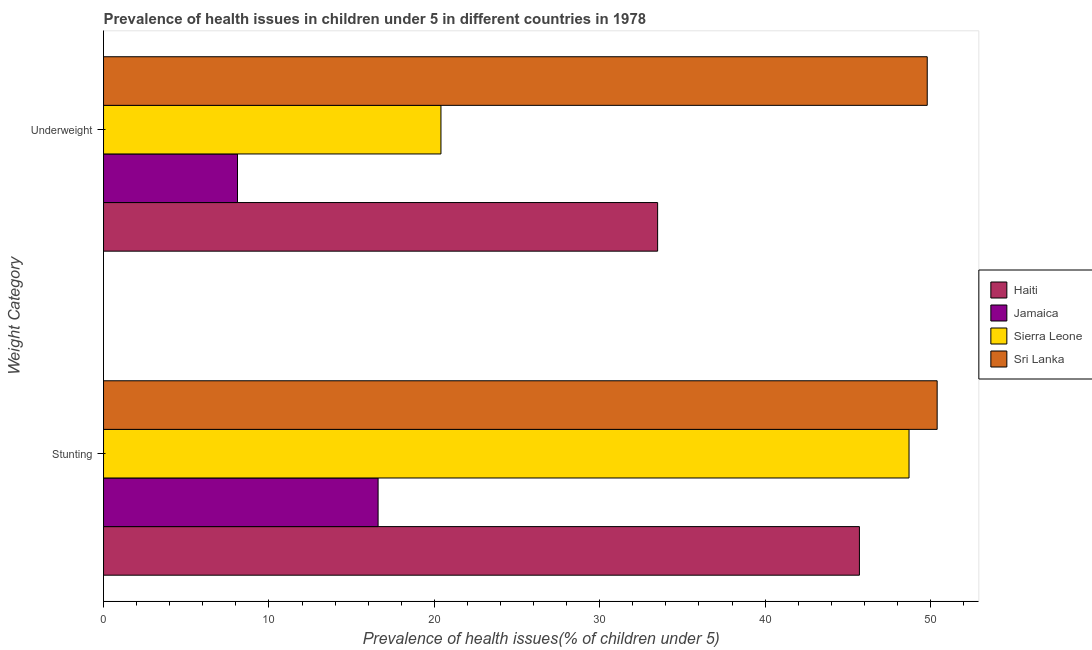How many different coloured bars are there?
Ensure brevity in your answer.  4. Are the number of bars on each tick of the Y-axis equal?
Your answer should be very brief. Yes. How many bars are there on the 2nd tick from the top?
Provide a succinct answer. 4. What is the label of the 2nd group of bars from the top?
Offer a very short reply. Stunting. What is the percentage of underweight children in Sierra Leone?
Your answer should be compact. 20.4. Across all countries, what is the maximum percentage of underweight children?
Your answer should be very brief. 49.8. Across all countries, what is the minimum percentage of underweight children?
Your answer should be compact. 8.1. In which country was the percentage of stunted children maximum?
Offer a terse response. Sri Lanka. In which country was the percentage of stunted children minimum?
Offer a terse response. Jamaica. What is the total percentage of stunted children in the graph?
Your response must be concise. 161.4. What is the difference between the percentage of stunted children in Haiti and that in Jamaica?
Give a very brief answer. 29.1. What is the difference between the percentage of stunted children in Haiti and the percentage of underweight children in Sri Lanka?
Provide a succinct answer. -4.1. What is the average percentage of stunted children per country?
Provide a succinct answer. 40.35. What is the difference between the percentage of underweight children and percentage of stunted children in Jamaica?
Make the answer very short. -8.5. What is the ratio of the percentage of stunted children in Jamaica to that in Haiti?
Provide a short and direct response. 0.36. Is the percentage of underweight children in Haiti less than that in Jamaica?
Keep it short and to the point. No. In how many countries, is the percentage of stunted children greater than the average percentage of stunted children taken over all countries?
Make the answer very short. 3. What does the 3rd bar from the top in Underweight represents?
Give a very brief answer. Jamaica. What does the 4th bar from the bottom in Stunting represents?
Your answer should be very brief. Sri Lanka. Are all the bars in the graph horizontal?
Your response must be concise. Yes. How many countries are there in the graph?
Your response must be concise. 4. Does the graph contain any zero values?
Keep it short and to the point. No. How are the legend labels stacked?
Your response must be concise. Vertical. What is the title of the graph?
Keep it short and to the point. Prevalence of health issues in children under 5 in different countries in 1978. Does "Cuba" appear as one of the legend labels in the graph?
Keep it short and to the point. No. What is the label or title of the X-axis?
Ensure brevity in your answer.  Prevalence of health issues(% of children under 5). What is the label or title of the Y-axis?
Provide a succinct answer. Weight Category. What is the Prevalence of health issues(% of children under 5) in Haiti in Stunting?
Provide a succinct answer. 45.7. What is the Prevalence of health issues(% of children under 5) in Jamaica in Stunting?
Your answer should be very brief. 16.6. What is the Prevalence of health issues(% of children under 5) of Sierra Leone in Stunting?
Your answer should be compact. 48.7. What is the Prevalence of health issues(% of children under 5) of Sri Lanka in Stunting?
Ensure brevity in your answer.  50.4. What is the Prevalence of health issues(% of children under 5) in Haiti in Underweight?
Provide a short and direct response. 33.5. What is the Prevalence of health issues(% of children under 5) of Jamaica in Underweight?
Offer a very short reply. 8.1. What is the Prevalence of health issues(% of children under 5) of Sierra Leone in Underweight?
Provide a short and direct response. 20.4. What is the Prevalence of health issues(% of children under 5) in Sri Lanka in Underweight?
Offer a very short reply. 49.8. Across all Weight Category, what is the maximum Prevalence of health issues(% of children under 5) in Haiti?
Ensure brevity in your answer.  45.7. Across all Weight Category, what is the maximum Prevalence of health issues(% of children under 5) of Jamaica?
Your answer should be very brief. 16.6. Across all Weight Category, what is the maximum Prevalence of health issues(% of children under 5) in Sierra Leone?
Make the answer very short. 48.7. Across all Weight Category, what is the maximum Prevalence of health issues(% of children under 5) in Sri Lanka?
Your answer should be very brief. 50.4. Across all Weight Category, what is the minimum Prevalence of health issues(% of children under 5) of Haiti?
Offer a terse response. 33.5. Across all Weight Category, what is the minimum Prevalence of health issues(% of children under 5) in Jamaica?
Your answer should be very brief. 8.1. Across all Weight Category, what is the minimum Prevalence of health issues(% of children under 5) of Sierra Leone?
Ensure brevity in your answer.  20.4. Across all Weight Category, what is the minimum Prevalence of health issues(% of children under 5) in Sri Lanka?
Make the answer very short. 49.8. What is the total Prevalence of health issues(% of children under 5) in Haiti in the graph?
Give a very brief answer. 79.2. What is the total Prevalence of health issues(% of children under 5) in Jamaica in the graph?
Your answer should be compact. 24.7. What is the total Prevalence of health issues(% of children under 5) in Sierra Leone in the graph?
Your response must be concise. 69.1. What is the total Prevalence of health issues(% of children under 5) in Sri Lanka in the graph?
Your response must be concise. 100.2. What is the difference between the Prevalence of health issues(% of children under 5) of Jamaica in Stunting and that in Underweight?
Give a very brief answer. 8.5. What is the difference between the Prevalence of health issues(% of children under 5) of Sierra Leone in Stunting and that in Underweight?
Your response must be concise. 28.3. What is the difference between the Prevalence of health issues(% of children under 5) of Sri Lanka in Stunting and that in Underweight?
Offer a terse response. 0.6. What is the difference between the Prevalence of health issues(% of children under 5) of Haiti in Stunting and the Prevalence of health issues(% of children under 5) of Jamaica in Underweight?
Keep it short and to the point. 37.6. What is the difference between the Prevalence of health issues(% of children under 5) in Haiti in Stunting and the Prevalence of health issues(% of children under 5) in Sierra Leone in Underweight?
Keep it short and to the point. 25.3. What is the difference between the Prevalence of health issues(% of children under 5) of Jamaica in Stunting and the Prevalence of health issues(% of children under 5) of Sri Lanka in Underweight?
Provide a succinct answer. -33.2. What is the average Prevalence of health issues(% of children under 5) of Haiti per Weight Category?
Your response must be concise. 39.6. What is the average Prevalence of health issues(% of children under 5) in Jamaica per Weight Category?
Your response must be concise. 12.35. What is the average Prevalence of health issues(% of children under 5) in Sierra Leone per Weight Category?
Provide a short and direct response. 34.55. What is the average Prevalence of health issues(% of children under 5) in Sri Lanka per Weight Category?
Keep it short and to the point. 50.1. What is the difference between the Prevalence of health issues(% of children under 5) of Haiti and Prevalence of health issues(% of children under 5) of Jamaica in Stunting?
Provide a succinct answer. 29.1. What is the difference between the Prevalence of health issues(% of children under 5) in Haiti and Prevalence of health issues(% of children under 5) in Sri Lanka in Stunting?
Ensure brevity in your answer.  -4.7. What is the difference between the Prevalence of health issues(% of children under 5) in Jamaica and Prevalence of health issues(% of children under 5) in Sierra Leone in Stunting?
Make the answer very short. -32.1. What is the difference between the Prevalence of health issues(% of children under 5) of Jamaica and Prevalence of health issues(% of children under 5) of Sri Lanka in Stunting?
Keep it short and to the point. -33.8. What is the difference between the Prevalence of health issues(% of children under 5) of Sierra Leone and Prevalence of health issues(% of children under 5) of Sri Lanka in Stunting?
Keep it short and to the point. -1.7. What is the difference between the Prevalence of health issues(% of children under 5) of Haiti and Prevalence of health issues(% of children under 5) of Jamaica in Underweight?
Provide a short and direct response. 25.4. What is the difference between the Prevalence of health issues(% of children under 5) in Haiti and Prevalence of health issues(% of children under 5) in Sri Lanka in Underweight?
Make the answer very short. -16.3. What is the difference between the Prevalence of health issues(% of children under 5) in Jamaica and Prevalence of health issues(% of children under 5) in Sri Lanka in Underweight?
Ensure brevity in your answer.  -41.7. What is the difference between the Prevalence of health issues(% of children under 5) of Sierra Leone and Prevalence of health issues(% of children under 5) of Sri Lanka in Underweight?
Make the answer very short. -29.4. What is the ratio of the Prevalence of health issues(% of children under 5) of Haiti in Stunting to that in Underweight?
Give a very brief answer. 1.36. What is the ratio of the Prevalence of health issues(% of children under 5) of Jamaica in Stunting to that in Underweight?
Give a very brief answer. 2.05. What is the ratio of the Prevalence of health issues(% of children under 5) of Sierra Leone in Stunting to that in Underweight?
Make the answer very short. 2.39. What is the ratio of the Prevalence of health issues(% of children under 5) of Sri Lanka in Stunting to that in Underweight?
Ensure brevity in your answer.  1.01. What is the difference between the highest and the second highest Prevalence of health issues(% of children under 5) in Haiti?
Provide a short and direct response. 12.2. What is the difference between the highest and the second highest Prevalence of health issues(% of children under 5) in Jamaica?
Your answer should be very brief. 8.5. What is the difference between the highest and the second highest Prevalence of health issues(% of children under 5) in Sierra Leone?
Offer a very short reply. 28.3. What is the difference between the highest and the second highest Prevalence of health issues(% of children under 5) of Sri Lanka?
Your response must be concise. 0.6. What is the difference between the highest and the lowest Prevalence of health issues(% of children under 5) of Jamaica?
Keep it short and to the point. 8.5. What is the difference between the highest and the lowest Prevalence of health issues(% of children under 5) in Sierra Leone?
Your answer should be compact. 28.3. 